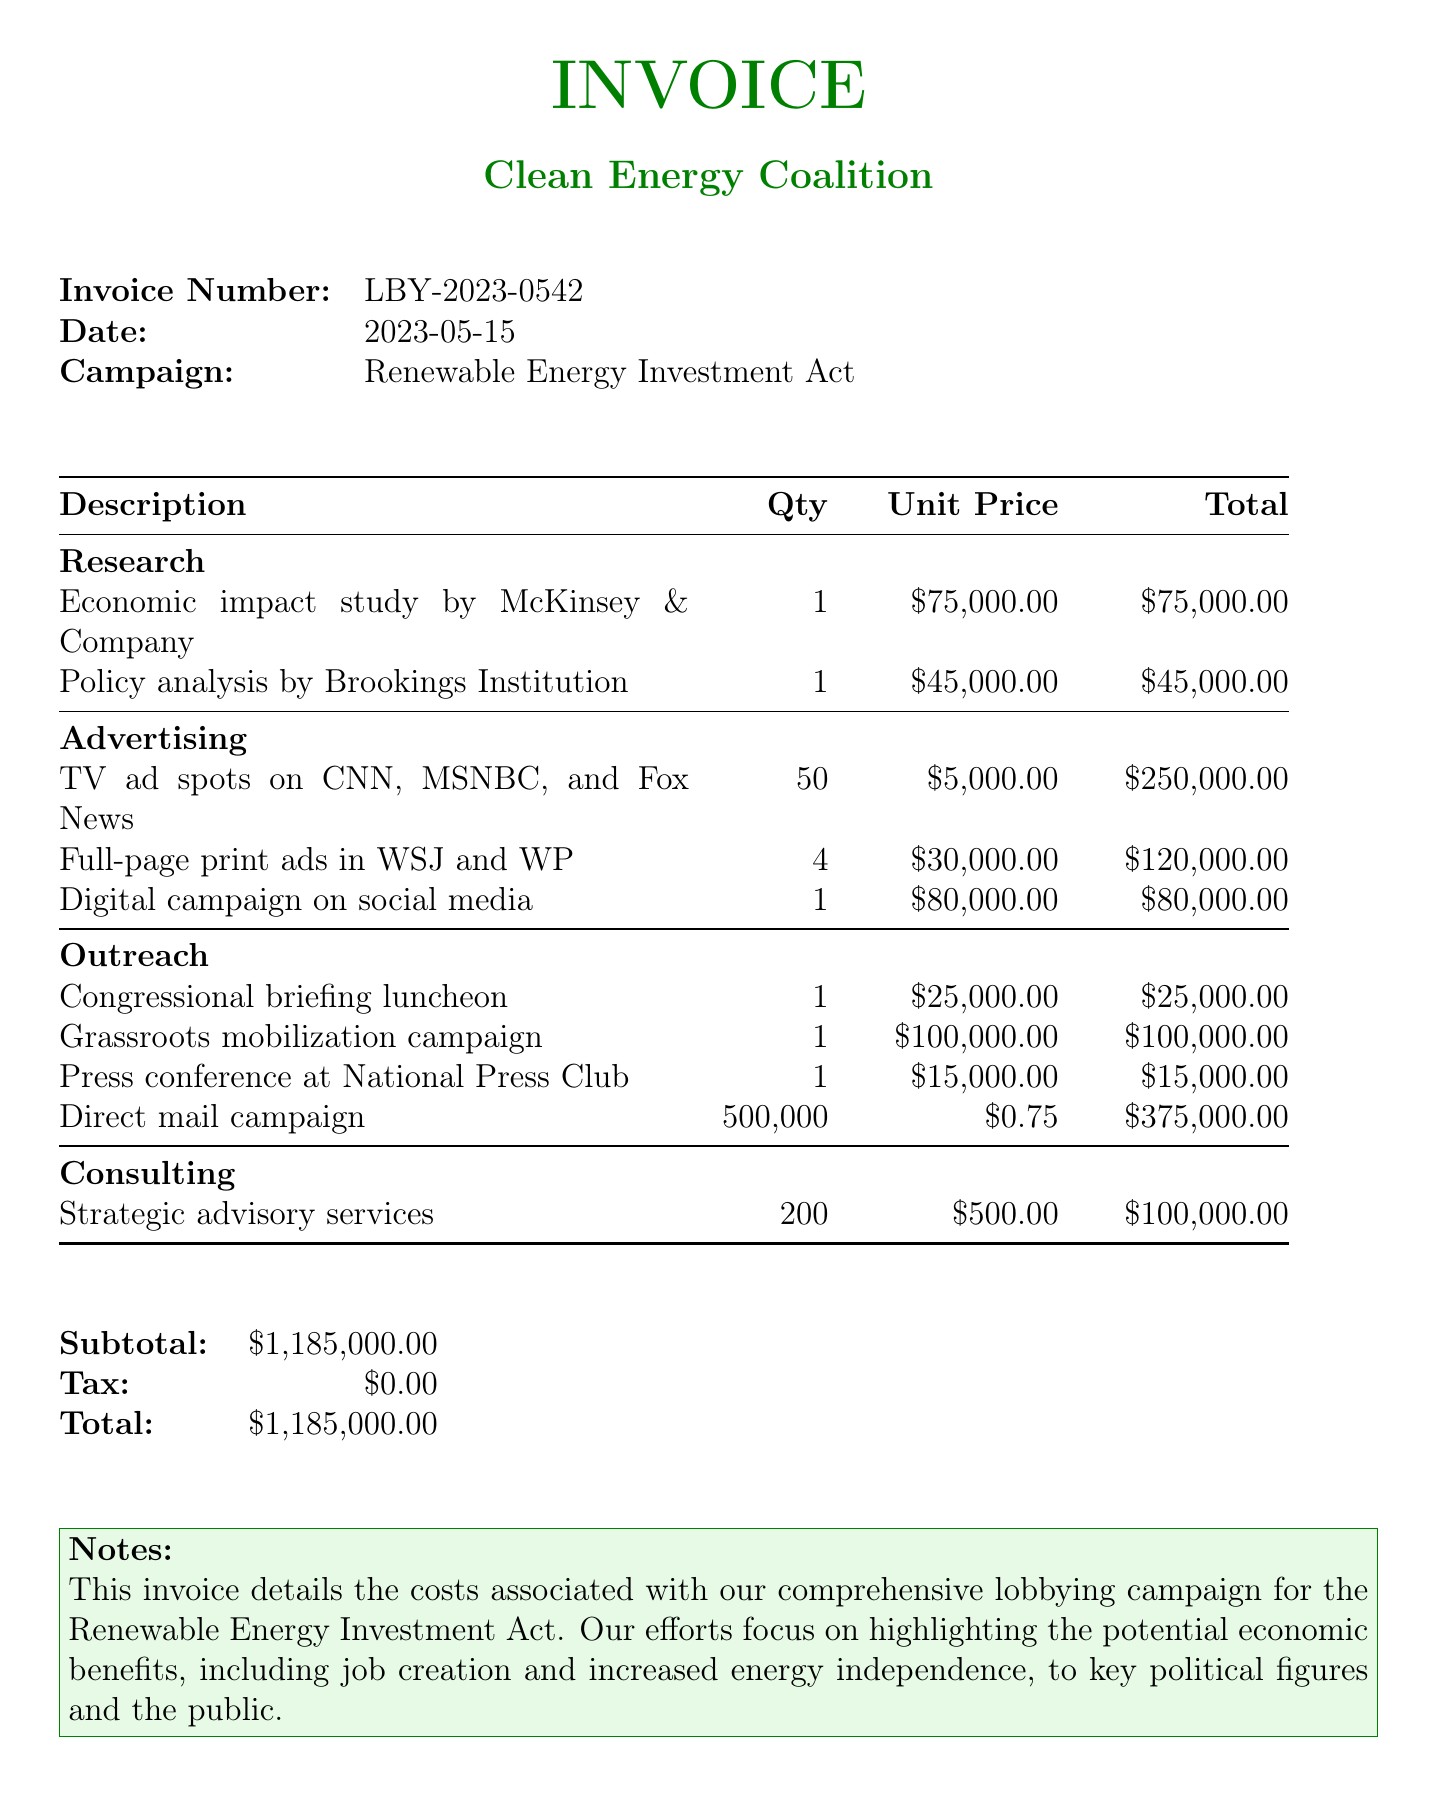what is the invoice number? The invoice number is listed clearly at the top of the document.
Answer: LBY-2023-0542 what is the total amount billed? The total amount is found at the bottom of the invoice after the subtotal and tax are listed.
Answer: $1,185,000.00 what campaign is this invoice for? The campaign name is specified in the header of the invoice.
Answer: Renewable Energy Investment Act how many TV ad spots were purchased? The quantity of TV ad spots is mentioned under the advertising category in the itemized list.
Answer: 50 who conducted the economic impact study? The name of the company that performed the study is provided in the research section of the invoice.
Answer: McKinsey & Company what was the cost of grassroots mobilization? The cost for grassroots mobilization is detailed in the outreach section of the invoice.
Answer: $100,000.00 how many full-page print ads were placed? The number of print ads is indicated in the advertising section of the document.
Answer: 4 what is the total amount spent on direct mail campaigns? The total is calculated based on the quantity and unit price listed in the outreach section.
Answer: $375,000.00 what is the purpose of the congressional briefing luncheon? The purpose is outlined in the notes at the bottom of the document discussing the campaign's objectives.
Answer: To highlight potential economic benefits 